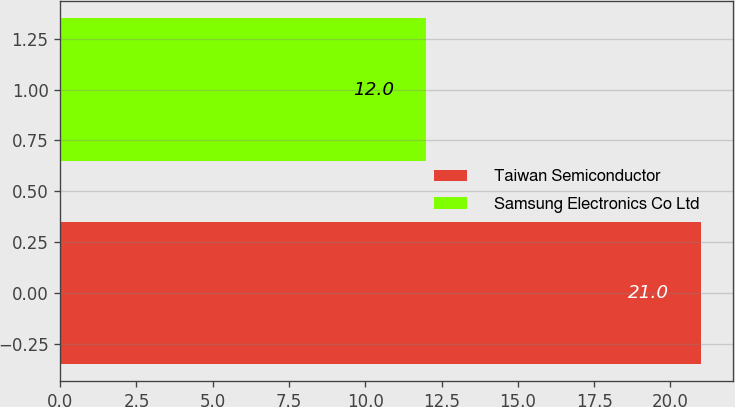<chart> <loc_0><loc_0><loc_500><loc_500><bar_chart><fcel>Taiwan Semiconductor<fcel>Samsung Electronics Co Ltd<nl><fcel>21<fcel>12<nl></chart> 